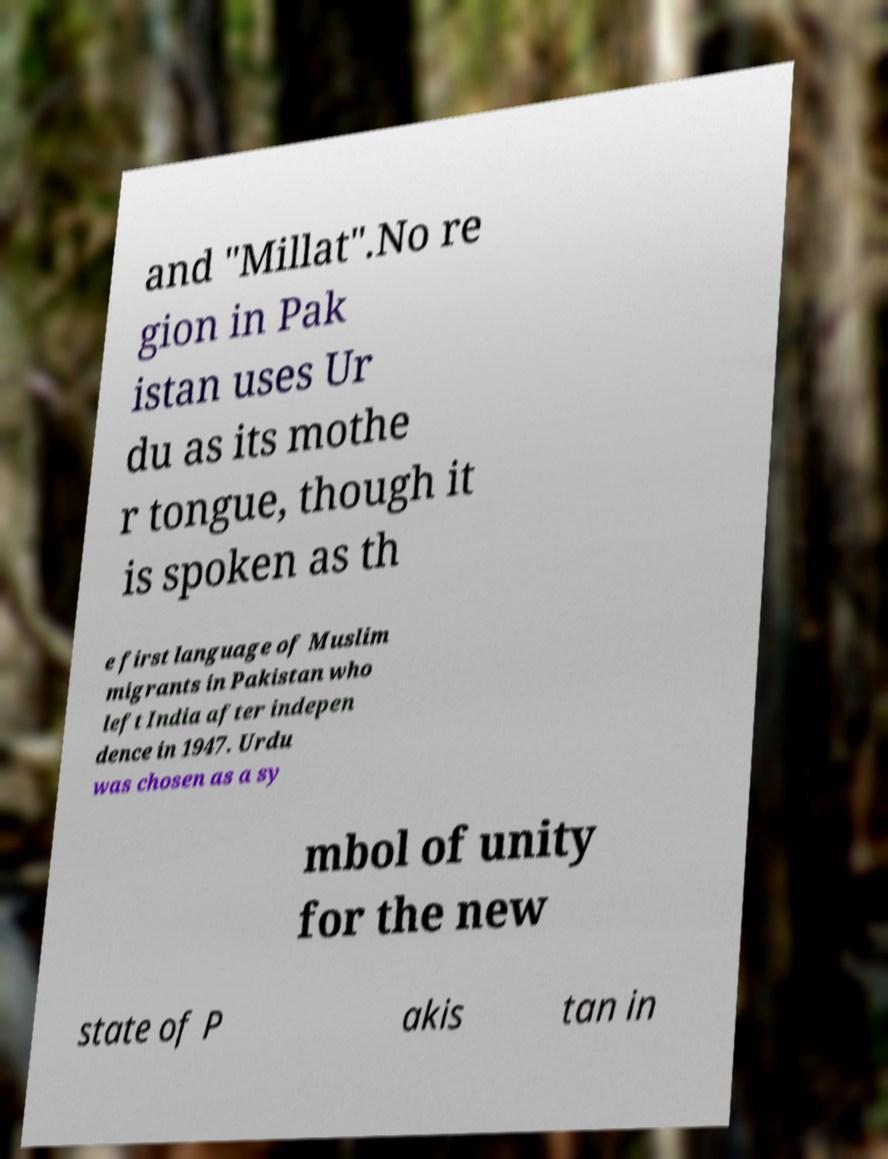Please identify and transcribe the text found in this image. and "Millat".No re gion in Pak istan uses Ur du as its mothe r tongue, though it is spoken as th e first language of Muslim migrants in Pakistan who left India after indepen dence in 1947. Urdu was chosen as a sy mbol of unity for the new state of P akis tan in 